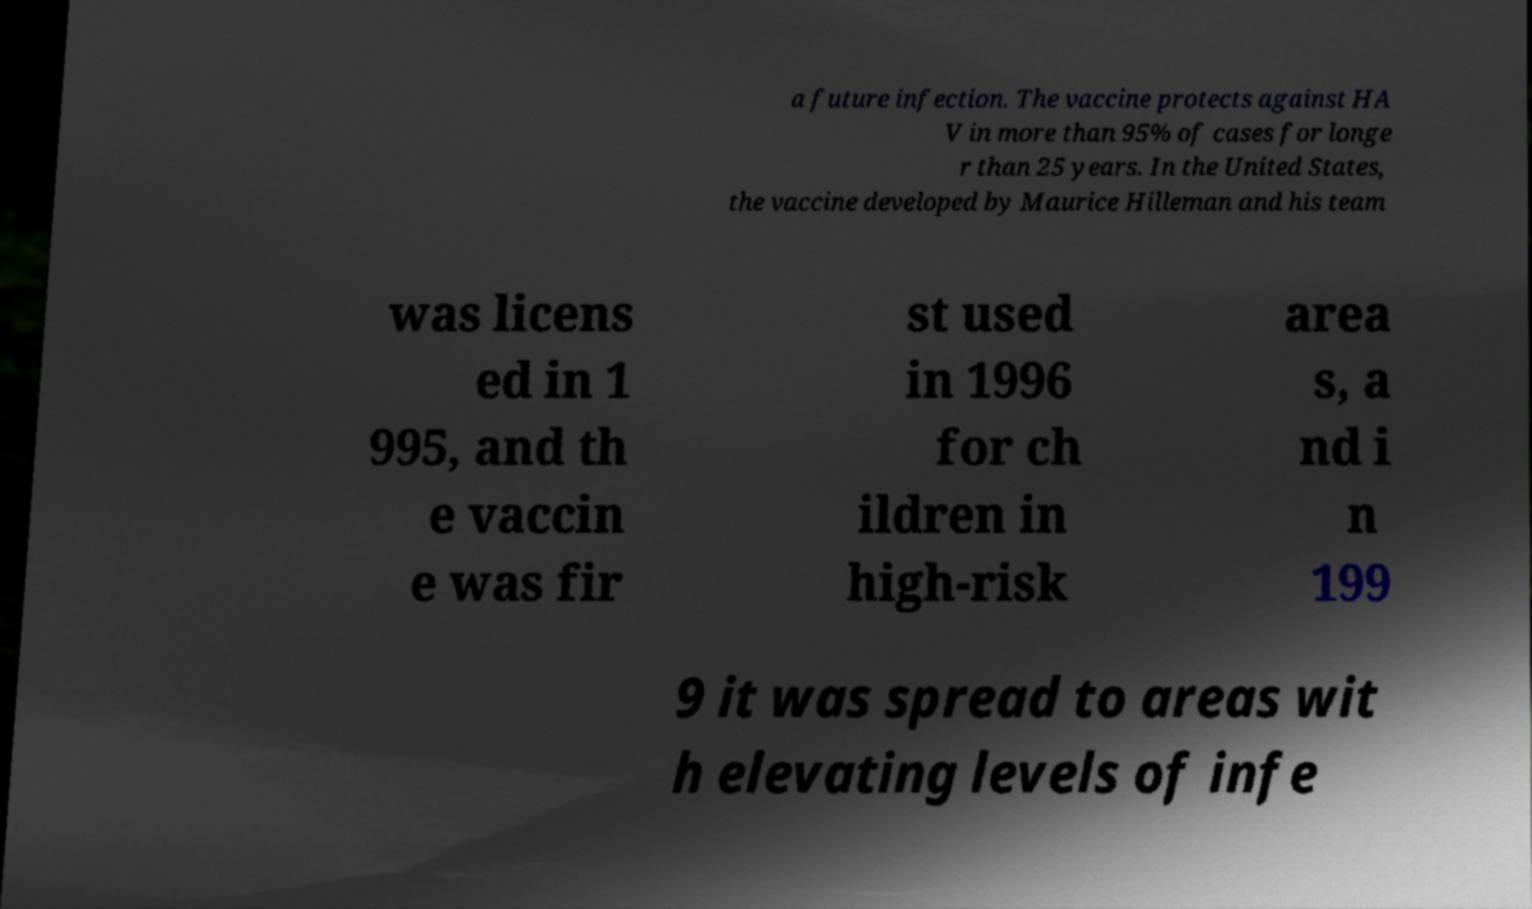For documentation purposes, I need the text within this image transcribed. Could you provide that? a future infection. The vaccine protects against HA V in more than 95% of cases for longe r than 25 years. In the United States, the vaccine developed by Maurice Hilleman and his team was licens ed in 1 995, and th e vaccin e was fir st used in 1996 for ch ildren in high-risk area s, a nd i n 199 9 it was spread to areas wit h elevating levels of infe 